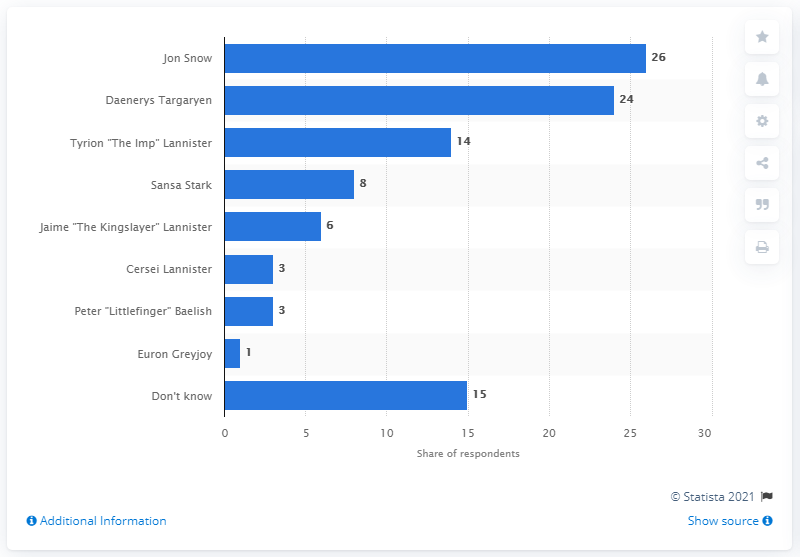Specify some key components in this picture. A majority of 24% of viewers believed that Daenerys Targaryen should rule from the Iron Throne. 